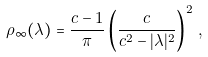<formula> <loc_0><loc_0><loc_500><loc_500>\rho _ { \infty } ( \lambda ) = \frac { c - 1 } { \pi } \left ( \frac { c } { c ^ { 2 } - | \lambda | ^ { 2 } } \right ) ^ { 2 } \, ,</formula> 